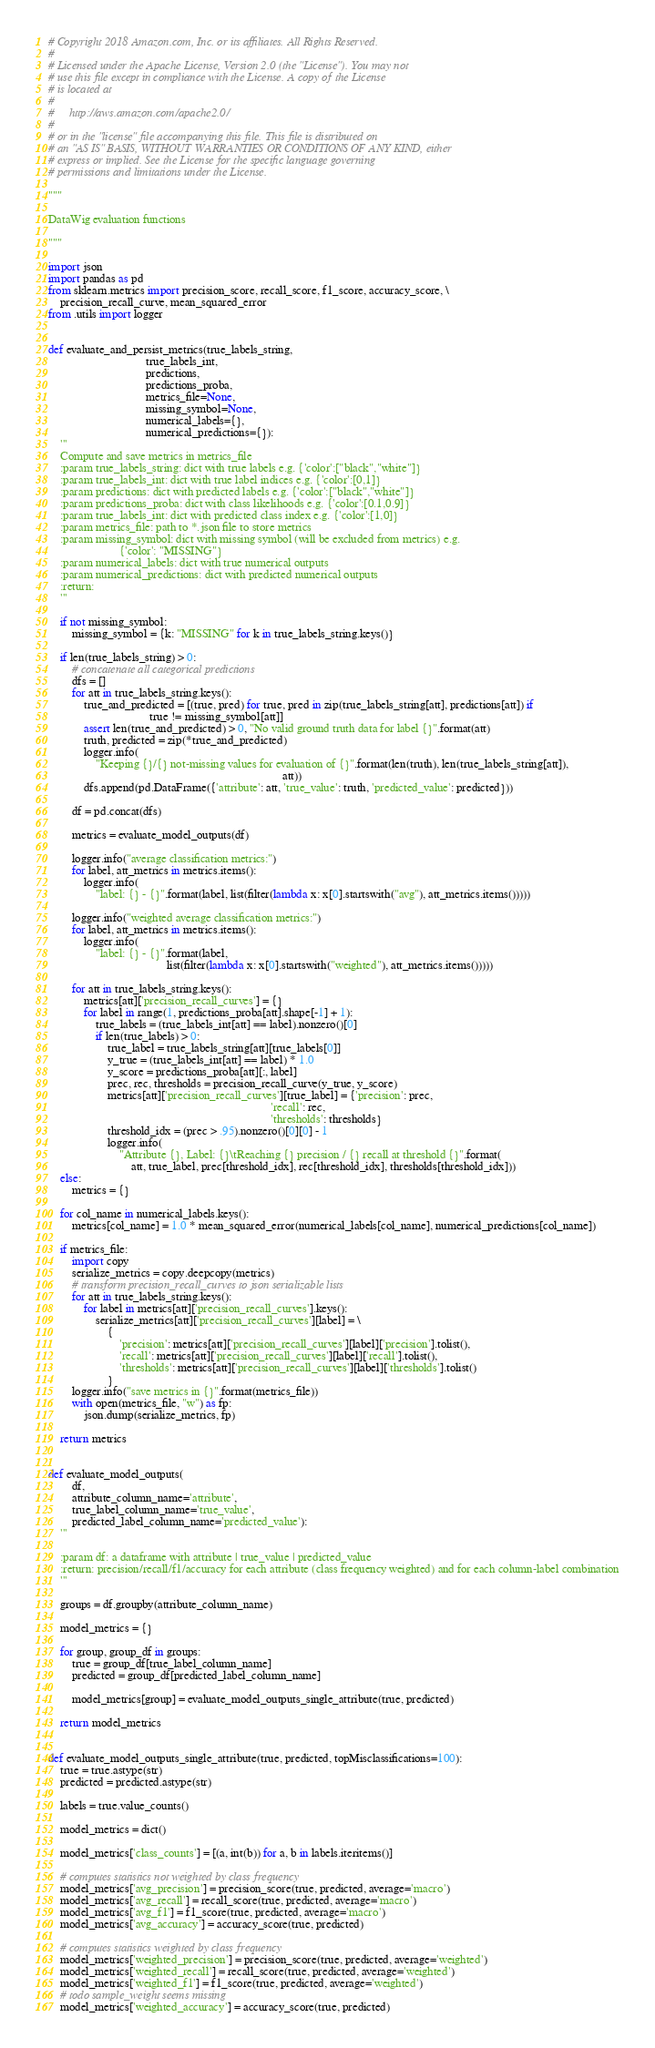<code> <loc_0><loc_0><loc_500><loc_500><_Python_># Copyright 2018 Amazon.com, Inc. or its affiliates. All Rights Reserved.
#
# Licensed under the Apache License, Version 2.0 (the "License"). You may not
# use this file except in compliance with the License. A copy of the License
# is located at
#
#     http://aws.amazon.com/apache2.0/
#
# or in the "license" file accompanying this file. This file is distributed on
# an "AS IS" BASIS, WITHOUT WARRANTIES OR CONDITIONS OF ANY KIND, either
# express or implied. See the License for the specific language governing
# permissions and limitations under the License.

"""

DataWig evaluation functions

"""

import json
import pandas as pd
from sklearn.metrics import precision_score, recall_score, f1_score, accuracy_score, \
    precision_recall_curve, mean_squared_error
from .utils import logger


def evaluate_and_persist_metrics(true_labels_string,
                                 true_labels_int,
                                 predictions,
                                 predictions_proba,
                                 metrics_file=None,
                                 missing_symbol=None,
                                 numerical_labels={},
                                 numerical_predictions={}):
    '''
    Compute and save metrics in metrics_file
    :param true_labels_string: dict with true labels e.g. {'color':["black","white"]}
    :param true_labels_int: dict with true label indices e.g. {'color':[0,1]}
    :param predictions: dict with predicted labels e.g. {'color':["black","white"]}
    :param predictions_proba: dict with class likelihoods e.g. {'color':[0.1,0.9]}
    :param true_labels_int: dict with predicted class index e.g. {'color':[1,0]}
    :param metrics_file: path to *.json file to store metrics
    :param missing_symbol: dict with missing symbol (will be excluded from metrics) e.g.
                        {'color': "MISSING"}
    :param numerical_labels: dict with true numerical outputs
    :param numerical_predictions: dict with predicted numerical outputs
    :return:
    '''

    if not missing_symbol:
        missing_symbol = {k: "MISSING" for k in true_labels_string.keys()}

    if len(true_labels_string) > 0:
        # concatenate all categorical predictions
        dfs = []
        for att in true_labels_string.keys():
            true_and_predicted = [(true, pred) for true, pred in zip(true_labels_string[att], predictions[att]) if
                                  true != missing_symbol[att]]
            assert len(true_and_predicted) > 0, "No valid ground truth data for label {}".format(att)
            truth, predicted = zip(*true_and_predicted)
            logger.info(
                "Keeping {}/{} not-missing values for evaluation of {}".format(len(truth), len(true_labels_string[att]),
                                                                               att))
            dfs.append(pd.DataFrame({'attribute': att, 'true_value': truth, 'predicted_value': predicted}))

        df = pd.concat(dfs)

        metrics = evaluate_model_outputs(df)

        logger.info("average classification metrics:")
        for label, att_metrics in metrics.items():
            logger.info(
                "label: {} - {}".format(label, list(filter(lambda x: x[0].startswith("avg"), att_metrics.items()))))

        logger.info("weighted average classification metrics:")
        for label, att_metrics in metrics.items():
            logger.info(
                "label: {} - {}".format(label,
                                        list(filter(lambda x: x[0].startswith("weighted"), att_metrics.items()))))

        for att in true_labels_string.keys():
            metrics[att]['precision_recall_curves'] = {}
            for label in range(1, predictions_proba[att].shape[-1] + 1):
                true_labels = (true_labels_int[att] == label).nonzero()[0]
                if len(true_labels) > 0:
                    true_label = true_labels_string[att][true_labels[0]]
                    y_true = (true_labels_int[att] == label) * 1.0
                    y_score = predictions_proba[att][:, label]
                    prec, rec, thresholds = precision_recall_curve(y_true, y_score)
                    metrics[att]['precision_recall_curves'][true_label] = {'precision': prec,
                                                                           'recall': rec,
                                                                           'thresholds': thresholds}
                    threshold_idx = (prec > .95).nonzero()[0][0] - 1
                    logger.info(
                        "Attribute {}, Label: {}\tReaching {} precision / {} recall at threshold {}".format(
                            att, true_label, prec[threshold_idx], rec[threshold_idx], thresholds[threshold_idx]))
    else:
        metrics = {}

    for col_name in numerical_labels.keys():
        metrics[col_name] = 1.0 * mean_squared_error(numerical_labels[col_name], numerical_predictions[col_name])

    if metrics_file:
        import copy
        serialize_metrics = copy.deepcopy(metrics)
        # transform precision_recall_curves to json serializable lists
        for att in true_labels_string.keys():
            for label in metrics[att]['precision_recall_curves'].keys():
                serialize_metrics[att]['precision_recall_curves'][label] = \
                    {
                        'precision': metrics[att]['precision_recall_curves'][label]['precision'].tolist(),
                        'recall': metrics[att]['precision_recall_curves'][label]['recall'].tolist(),
                        'thresholds': metrics[att]['precision_recall_curves'][label]['thresholds'].tolist()
                    }
        logger.info("save metrics in {}".format(metrics_file))
        with open(metrics_file, "w") as fp:
            json.dump(serialize_metrics, fp)

    return metrics


def evaluate_model_outputs(
        df,
        attribute_column_name='attribute',
        true_label_column_name='true_value',
        predicted_label_column_name='predicted_value'):
    '''

    :param df: a dataframe with attribute | true_value | predicted_value
    :return: precision/recall/f1/accuracy for each attribute (class frequency weighted) and for each column-label combination
    '''

    groups = df.groupby(attribute_column_name)

    model_metrics = {}

    for group, group_df in groups:
        true = group_df[true_label_column_name]
        predicted = group_df[predicted_label_column_name]

        model_metrics[group] = evaluate_model_outputs_single_attribute(true, predicted)

    return model_metrics


def evaluate_model_outputs_single_attribute(true, predicted, topMisclassifications=100):
    true = true.astype(str)
    predicted = predicted.astype(str)

    labels = true.value_counts()

    model_metrics = dict()

    model_metrics['class_counts'] = [(a, int(b)) for a, b in labels.iteritems()]

    # computes statistics not weighted by class frequency
    model_metrics['avg_precision'] = precision_score(true, predicted, average='macro')
    model_metrics['avg_recall'] = recall_score(true, predicted, average='macro')
    model_metrics['avg_f1'] = f1_score(true, predicted, average='macro')
    model_metrics['avg_accuracy'] = accuracy_score(true, predicted)

    # computes statistics weighted by class frequency
    model_metrics['weighted_precision'] = precision_score(true, predicted, average='weighted')
    model_metrics['weighted_recall'] = recall_score(true, predicted, average='weighted')
    model_metrics['weighted_f1'] = f1_score(true, predicted, average='weighted')
    # todo sample_weight seems missing
    model_metrics['weighted_accuracy'] = accuracy_score(true, predicted)
</code> 